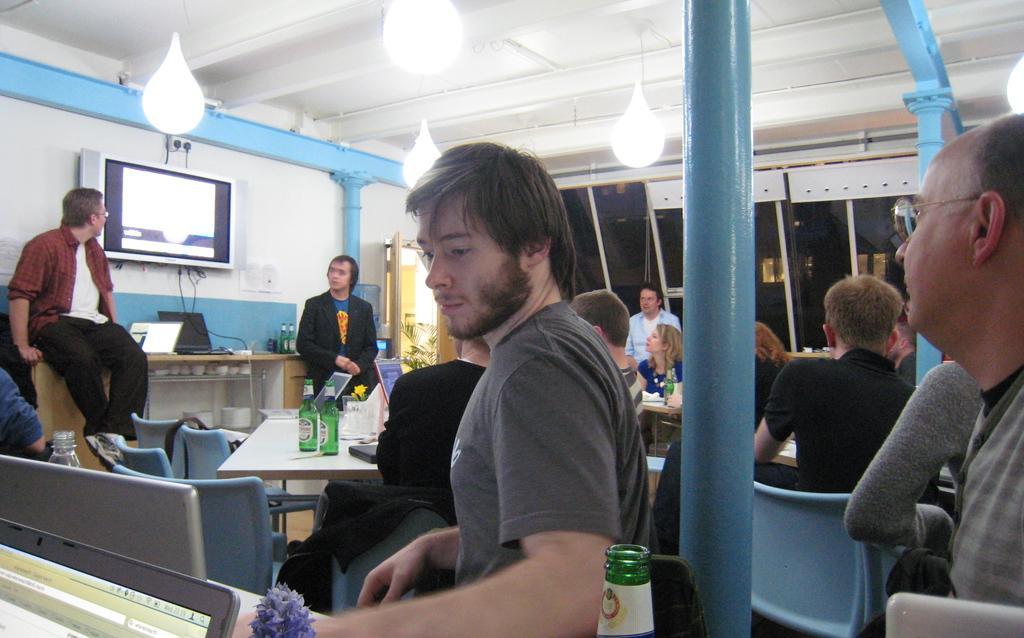How would you summarize this image in a sentence or two? In this image we can see people, poles, tables, door windows and plant. Above these tables there are laptops, bottles and things. Television is on the wall. Light are attached to the roof. 